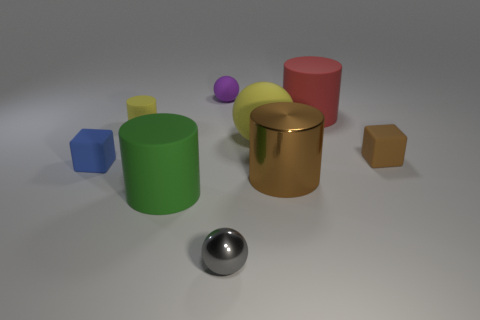How many objects are there, and can you describe their shapes? There are seven distinct objects: a reflective sphere, a small purple sphere, a yellow cube, a green cylinder, a shiny gold cylinder, a red cylinder, and a brown hexagonal prism. 